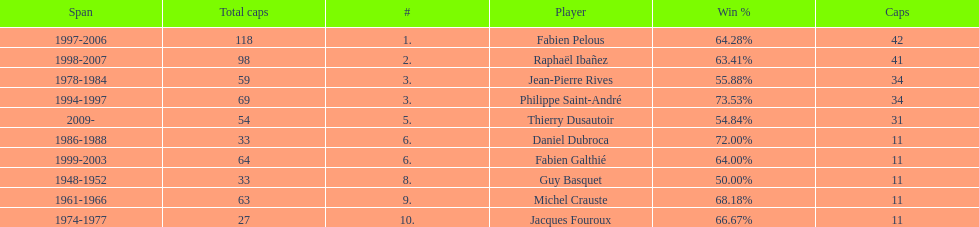How many caps did guy basquet accrue during his career? 33. 